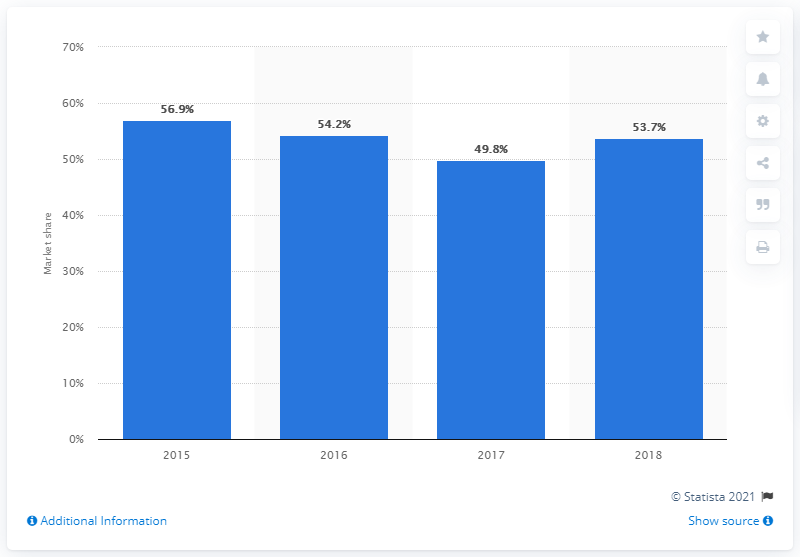Indicate a few pertinent items in this graphic. In 2017, Eni held 49.8% of the Italian gas supply market. Eni held a market share of 53.7% in Italy in 2017. In 2015, Eni accounted for 56.9% of the Italian gas market in terms of volume. 